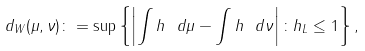Convert formula to latex. <formula><loc_0><loc_0><loc_500><loc_500>d _ { W } ( \mu , \nu ) \colon = \sup \left \{ \left | \int h \ d \mu - \int h \ d \nu \right | \colon \| h \| _ { L } \leq 1 \right \} ,</formula> 